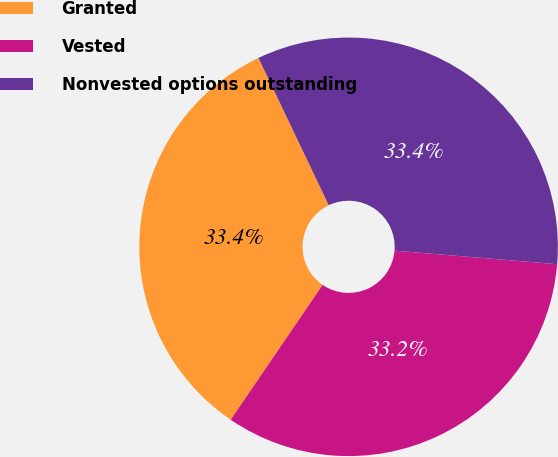Convert chart to OTSL. <chart><loc_0><loc_0><loc_500><loc_500><pie_chart><fcel>Granted<fcel>Vested<fcel>Nonvested options outstanding<nl><fcel>33.39%<fcel>33.2%<fcel>33.41%<nl></chart> 